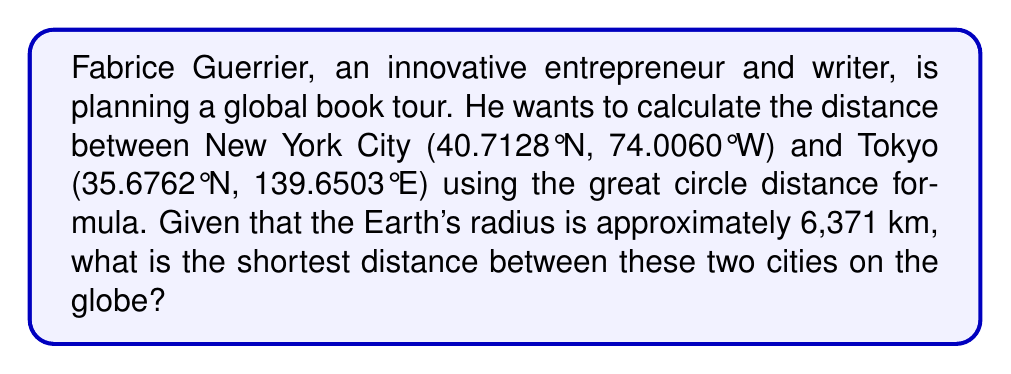What is the answer to this math problem? To solve this problem, we'll use the Haversine formula, which calculates the great circle distance between two points on a sphere given their latitudes and longitudes. Let's break it down step-by-step:

1. Convert the latitudes and longitudes from degrees to radians:
   $$\phi_1 = 40.7128° \times \frac{\pi}{180} = 0.7103 \text{ rad}$$
   $$\lambda_1 = -74.0060° \times \frac{\pi}{180} = -1.2917 \text{ rad}$$
   $$\phi_2 = 35.6762° \times \frac{\pi}{180} = 0.6226 \text{ rad}$$
   $$\lambda_2 = 139.6503° \times \frac{\pi}{180} = 2.4372 \text{ rad}$$

2. Calculate the difference in longitude:
   $$\Delta\lambda = \lambda_2 - \lambda_1 = 2.4372 - (-1.2917) = 3.7289 \text{ rad}$$

3. Apply the Haversine formula:
   $$a = \sin^2\left(\frac{\phi_2 - \phi_1}{2}\right) + \cos(\phi_1)\cos(\phi_2)\sin^2\left(\frac{\Delta\lambda}{2}\right)$$
   
   $$a = \sin^2\left(\frac{0.6226 - 0.7103}{2}\right) + \cos(0.7103)\cos(0.6226)\sin^2\left(\frac{3.7289}{2}\right)$$
   
   $$a = 0.0004 + (0.7578 \times 0.8131 \times 0.8714) = 0.5385$$

4. Calculate the central angle:
   $$c = 2 \times \arctan2(\sqrt{a}, \sqrt{1-a})$$
   $$c = 2 \times \arctan2(\sqrt{0.5385}, \sqrt{1-0.5385}) = 1.6995 \text{ rad}$$

5. Compute the distance:
   $$d = R \times c$$
   Where R is the Earth's radius (6,371 km)
   $$d = 6371 \times 1.6995 = 10,828.5 \text{ km}$$

Therefore, the shortest distance between New York City and Tokyo is approximately 10,828.5 km.
Answer: 10,828.5 km 